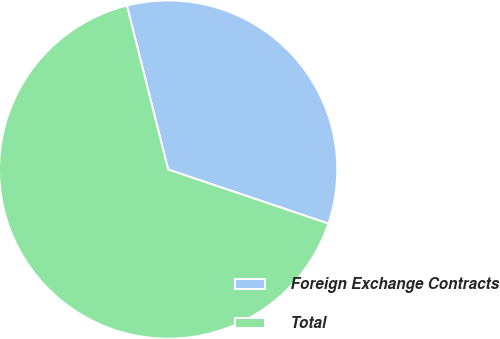Convert chart to OTSL. <chart><loc_0><loc_0><loc_500><loc_500><pie_chart><fcel>Foreign Exchange Contracts<fcel>Total<nl><fcel>34.1%<fcel>65.9%<nl></chart> 